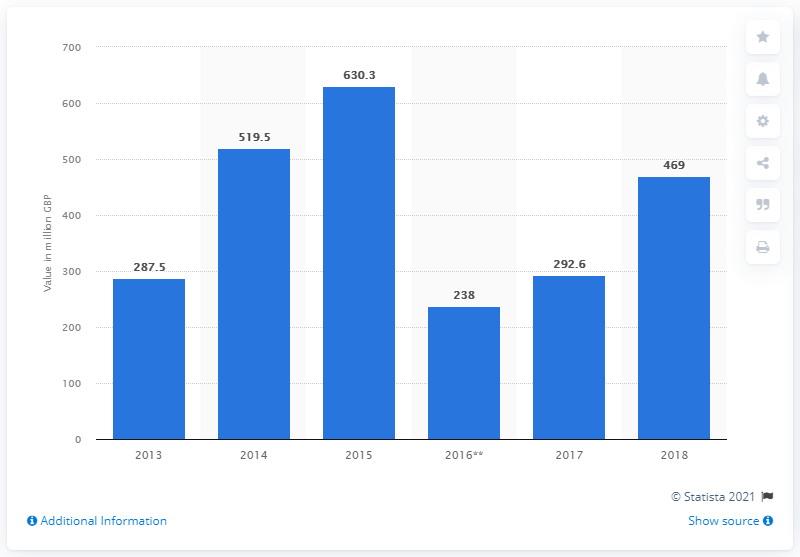Mention a couple of crucial points in this snapshot. In 2018, ISG generated 469 million dollars in engineering services. 